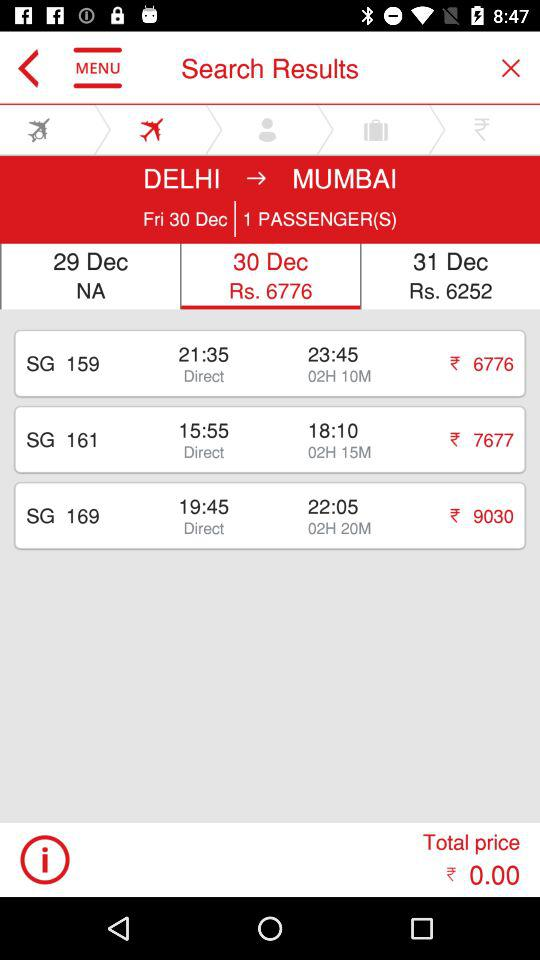How many passengers will be travelling? There is 1 passenger. 